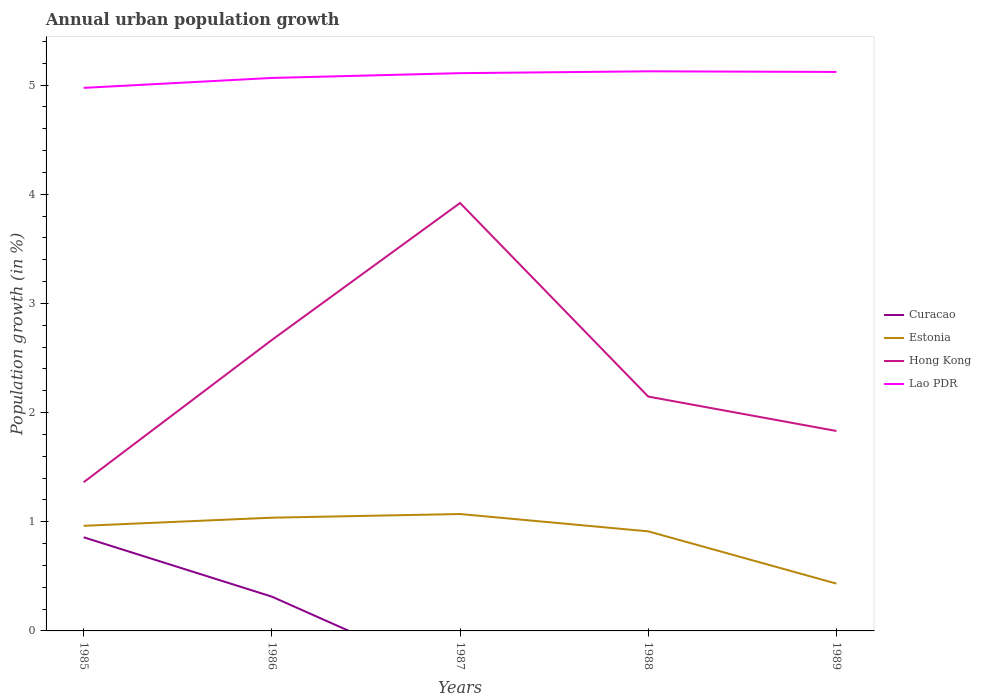Is the number of lines equal to the number of legend labels?
Ensure brevity in your answer.  No. Across all years, what is the maximum percentage of urban population growth in Hong Kong?
Your answer should be compact. 1.36. What is the total percentage of urban population growth in Hong Kong in the graph?
Keep it short and to the point. -0.78. What is the difference between the highest and the second highest percentage of urban population growth in Hong Kong?
Ensure brevity in your answer.  2.56. What is the difference between the highest and the lowest percentage of urban population growth in Hong Kong?
Keep it short and to the point. 2. Are the values on the major ticks of Y-axis written in scientific E-notation?
Your answer should be compact. No. Does the graph contain any zero values?
Your answer should be compact. Yes. How many legend labels are there?
Your answer should be very brief. 4. What is the title of the graph?
Your response must be concise. Annual urban population growth. Does "Virgin Islands" appear as one of the legend labels in the graph?
Your answer should be compact. No. What is the label or title of the Y-axis?
Provide a succinct answer. Population growth (in %). What is the Population growth (in %) in Curacao in 1985?
Offer a very short reply. 0.86. What is the Population growth (in %) in Estonia in 1985?
Offer a terse response. 0.96. What is the Population growth (in %) of Hong Kong in 1985?
Keep it short and to the point. 1.36. What is the Population growth (in %) of Lao PDR in 1985?
Make the answer very short. 4.97. What is the Population growth (in %) of Curacao in 1986?
Offer a very short reply. 0.31. What is the Population growth (in %) of Estonia in 1986?
Your answer should be compact. 1.04. What is the Population growth (in %) of Hong Kong in 1986?
Your answer should be very brief. 2.66. What is the Population growth (in %) of Lao PDR in 1986?
Ensure brevity in your answer.  5.06. What is the Population growth (in %) in Estonia in 1987?
Offer a very short reply. 1.07. What is the Population growth (in %) in Hong Kong in 1987?
Provide a succinct answer. 3.92. What is the Population growth (in %) in Lao PDR in 1987?
Make the answer very short. 5.11. What is the Population growth (in %) in Curacao in 1988?
Your response must be concise. 0. What is the Population growth (in %) of Estonia in 1988?
Your answer should be very brief. 0.91. What is the Population growth (in %) of Hong Kong in 1988?
Offer a terse response. 2.15. What is the Population growth (in %) in Lao PDR in 1988?
Offer a terse response. 5.13. What is the Population growth (in %) of Estonia in 1989?
Provide a succinct answer. 0.43. What is the Population growth (in %) of Hong Kong in 1989?
Make the answer very short. 1.83. What is the Population growth (in %) of Lao PDR in 1989?
Your answer should be very brief. 5.12. Across all years, what is the maximum Population growth (in %) in Curacao?
Keep it short and to the point. 0.86. Across all years, what is the maximum Population growth (in %) in Estonia?
Give a very brief answer. 1.07. Across all years, what is the maximum Population growth (in %) in Hong Kong?
Offer a very short reply. 3.92. Across all years, what is the maximum Population growth (in %) of Lao PDR?
Offer a very short reply. 5.13. Across all years, what is the minimum Population growth (in %) of Curacao?
Give a very brief answer. 0. Across all years, what is the minimum Population growth (in %) of Estonia?
Provide a succinct answer. 0.43. Across all years, what is the minimum Population growth (in %) in Hong Kong?
Make the answer very short. 1.36. Across all years, what is the minimum Population growth (in %) in Lao PDR?
Your answer should be very brief. 4.97. What is the total Population growth (in %) of Curacao in the graph?
Ensure brevity in your answer.  1.17. What is the total Population growth (in %) of Estonia in the graph?
Provide a short and direct response. 4.42. What is the total Population growth (in %) in Hong Kong in the graph?
Keep it short and to the point. 11.92. What is the total Population growth (in %) in Lao PDR in the graph?
Offer a terse response. 25.39. What is the difference between the Population growth (in %) of Curacao in 1985 and that in 1986?
Your answer should be very brief. 0.54. What is the difference between the Population growth (in %) in Estonia in 1985 and that in 1986?
Your answer should be compact. -0.07. What is the difference between the Population growth (in %) of Hong Kong in 1985 and that in 1986?
Your answer should be compact. -1.3. What is the difference between the Population growth (in %) of Lao PDR in 1985 and that in 1986?
Offer a very short reply. -0.09. What is the difference between the Population growth (in %) in Estonia in 1985 and that in 1987?
Your response must be concise. -0.11. What is the difference between the Population growth (in %) in Hong Kong in 1985 and that in 1987?
Your answer should be very brief. -2.56. What is the difference between the Population growth (in %) of Lao PDR in 1985 and that in 1987?
Your answer should be compact. -0.13. What is the difference between the Population growth (in %) in Estonia in 1985 and that in 1988?
Offer a very short reply. 0.05. What is the difference between the Population growth (in %) in Hong Kong in 1985 and that in 1988?
Provide a succinct answer. -0.78. What is the difference between the Population growth (in %) of Lao PDR in 1985 and that in 1988?
Your response must be concise. -0.15. What is the difference between the Population growth (in %) of Estonia in 1985 and that in 1989?
Make the answer very short. 0.53. What is the difference between the Population growth (in %) in Hong Kong in 1985 and that in 1989?
Keep it short and to the point. -0.47. What is the difference between the Population growth (in %) of Lao PDR in 1985 and that in 1989?
Your answer should be very brief. -0.15. What is the difference between the Population growth (in %) in Estonia in 1986 and that in 1987?
Keep it short and to the point. -0.03. What is the difference between the Population growth (in %) of Hong Kong in 1986 and that in 1987?
Provide a short and direct response. -1.25. What is the difference between the Population growth (in %) in Lao PDR in 1986 and that in 1987?
Give a very brief answer. -0.04. What is the difference between the Population growth (in %) in Estonia in 1986 and that in 1988?
Offer a very short reply. 0.13. What is the difference between the Population growth (in %) in Hong Kong in 1986 and that in 1988?
Provide a short and direct response. 0.52. What is the difference between the Population growth (in %) of Lao PDR in 1986 and that in 1988?
Ensure brevity in your answer.  -0.06. What is the difference between the Population growth (in %) of Estonia in 1986 and that in 1989?
Provide a succinct answer. 0.6. What is the difference between the Population growth (in %) of Hong Kong in 1986 and that in 1989?
Your response must be concise. 0.83. What is the difference between the Population growth (in %) in Lao PDR in 1986 and that in 1989?
Provide a short and direct response. -0.06. What is the difference between the Population growth (in %) of Estonia in 1987 and that in 1988?
Your answer should be very brief. 0.16. What is the difference between the Population growth (in %) of Hong Kong in 1987 and that in 1988?
Your response must be concise. 1.77. What is the difference between the Population growth (in %) in Lao PDR in 1987 and that in 1988?
Your response must be concise. -0.02. What is the difference between the Population growth (in %) of Estonia in 1987 and that in 1989?
Keep it short and to the point. 0.64. What is the difference between the Population growth (in %) of Hong Kong in 1987 and that in 1989?
Your answer should be compact. 2.09. What is the difference between the Population growth (in %) in Lao PDR in 1987 and that in 1989?
Keep it short and to the point. -0.01. What is the difference between the Population growth (in %) in Estonia in 1988 and that in 1989?
Give a very brief answer. 0.48. What is the difference between the Population growth (in %) in Hong Kong in 1988 and that in 1989?
Keep it short and to the point. 0.32. What is the difference between the Population growth (in %) of Lao PDR in 1988 and that in 1989?
Your response must be concise. 0.01. What is the difference between the Population growth (in %) of Curacao in 1985 and the Population growth (in %) of Estonia in 1986?
Keep it short and to the point. -0.18. What is the difference between the Population growth (in %) in Curacao in 1985 and the Population growth (in %) in Hong Kong in 1986?
Your answer should be compact. -1.81. What is the difference between the Population growth (in %) of Curacao in 1985 and the Population growth (in %) of Lao PDR in 1986?
Ensure brevity in your answer.  -4.21. What is the difference between the Population growth (in %) of Estonia in 1985 and the Population growth (in %) of Hong Kong in 1986?
Your answer should be very brief. -1.7. What is the difference between the Population growth (in %) in Estonia in 1985 and the Population growth (in %) in Lao PDR in 1986?
Your answer should be compact. -4.1. What is the difference between the Population growth (in %) of Hong Kong in 1985 and the Population growth (in %) of Lao PDR in 1986?
Offer a terse response. -3.7. What is the difference between the Population growth (in %) in Curacao in 1985 and the Population growth (in %) in Estonia in 1987?
Provide a short and direct response. -0.21. What is the difference between the Population growth (in %) in Curacao in 1985 and the Population growth (in %) in Hong Kong in 1987?
Offer a terse response. -3.06. What is the difference between the Population growth (in %) of Curacao in 1985 and the Population growth (in %) of Lao PDR in 1987?
Ensure brevity in your answer.  -4.25. What is the difference between the Population growth (in %) of Estonia in 1985 and the Population growth (in %) of Hong Kong in 1987?
Ensure brevity in your answer.  -2.96. What is the difference between the Population growth (in %) in Estonia in 1985 and the Population growth (in %) in Lao PDR in 1987?
Offer a terse response. -4.15. What is the difference between the Population growth (in %) of Hong Kong in 1985 and the Population growth (in %) of Lao PDR in 1987?
Keep it short and to the point. -3.75. What is the difference between the Population growth (in %) in Curacao in 1985 and the Population growth (in %) in Estonia in 1988?
Your answer should be very brief. -0.05. What is the difference between the Population growth (in %) in Curacao in 1985 and the Population growth (in %) in Hong Kong in 1988?
Offer a terse response. -1.29. What is the difference between the Population growth (in %) in Curacao in 1985 and the Population growth (in %) in Lao PDR in 1988?
Your response must be concise. -4.27. What is the difference between the Population growth (in %) in Estonia in 1985 and the Population growth (in %) in Hong Kong in 1988?
Offer a terse response. -1.18. What is the difference between the Population growth (in %) in Estonia in 1985 and the Population growth (in %) in Lao PDR in 1988?
Provide a short and direct response. -4.16. What is the difference between the Population growth (in %) of Hong Kong in 1985 and the Population growth (in %) of Lao PDR in 1988?
Offer a terse response. -3.76. What is the difference between the Population growth (in %) in Curacao in 1985 and the Population growth (in %) in Estonia in 1989?
Make the answer very short. 0.42. What is the difference between the Population growth (in %) of Curacao in 1985 and the Population growth (in %) of Hong Kong in 1989?
Make the answer very short. -0.97. What is the difference between the Population growth (in %) of Curacao in 1985 and the Population growth (in %) of Lao PDR in 1989?
Your answer should be very brief. -4.26. What is the difference between the Population growth (in %) of Estonia in 1985 and the Population growth (in %) of Hong Kong in 1989?
Your answer should be very brief. -0.87. What is the difference between the Population growth (in %) in Estonia in 1985 and the Population growth (in %) in Lao PDR in 1989?
Offer a very short reply. -4.16. What is the difference between the Population growth (in %) in Hong Kong in 1985 and the Population growth (in %) in Lao PDR in 1989?
Your answer should be compact. -3.76. What is the difference between the Population growth (in %) of Curacao in 1986 and the Population growth (in %) of Estonia in 1987?
Keep it short and to the point. -0.76. What is the difference between the Population growth (in %) in Curacao in 1986 and the Population growth (in %) in Hong Kong in 1987?
Your response must be concise. -3.61. What is the difference between the Population growth (in %) in Curacao in 1986 and the Population growth (in %) in Lao PDR in 1987?
Provide a short and direct response. -4.79. What is the difference between the Population growth (in %) in Estonia in 1986 and the Population growth (in %) in Hong Kong in 1987?
Ensure brevity in your answer.  -2.88. What is the difference between the Population growth (in %) in Estonia in 1986 and the Population growth (in %) in Lao PDR in 1987?
Your answer should be very brief. -4.07. What is the difference between the Population growth (in %) in Hong Kong in 1986 and the Population growth (in %) in Lao PDR in 1987?
Provide a succinct answer. -2.44. What is the difference between the Population growth (in %) of Curacao in 1986 and the Population growth (in %) of Estonia in 1988?
Your answer should be very brief. -0.6. What is the difference between the Population growth (in %) in Curacao in 1986 and the Population growth (in %) in Hong Kong in 1988?
Make the answer very short. -1.83. What is the difference between the Population growth (in %) of Curacao in 1986 and the Population growth (in %) of Lao PDR in 1988?
Your answer should be very brief. -4.81. What is the difference between the Population growth (in %) of Estonia in 1986 and the Population growth (in %) of Hong Kong in 1988?
Keep it short and to the point. -1.11. What is the difference between the Population growth (in %) in Estonia in 1986 and the Population growth (in %) in Lao PDR in 1988?
Your answer should be compact. -4.09. What is the difference between the Population growth (in %) in Hong Kong in 1986 and the Population growth (in %) in Lao PDR in 1988?
Your response must be concise. -2.46. What is the difference between the Population growth (in %) in Curacao in 1986 and the Population growth (in %) in Estonia in 1989?
Provide a short and direct response. -0.12. What is the difference between the Population growth (in %) in Curacao in 1986 and the Population growth (in %) in Hong Kong in 1989?
Your response must be concise. -1.52. What is the difference between the Population growth (in %) in Curacao in 1986 and the Population growth (in %) in Lao PDR in 1989?
Make the answer very short. -4.81. What is the difference between the Population growth (in %) in Estonia in 1986 and the Population growth (in %) in Hong Kong in 1989?
Your response must be concise. -0.79. What is the difference between the Population growth (in %) in Estonia in 1986 and the Population growth (in %) in Lao PDR in 1989?
Provide a succinct answer. -4.08. What is the difference between the Population growth (in %) in Hong Kong in 1986 and the Population growth (in %) in Lao PDR in 1989?
Your response must be concise. -2.45. What is the difference between the Population growth (in %) of Estonia in 1987 and the Population growth (in %) of Hong Kong in 1988?
Offer a terse response. -1.08. What is the difference between the Population growth (in %) in Estonia in 1987 and the Population growth (in %) in Lao PDR in 1988?
Make the answer very short. -4.05. What is the difference between the Population growth (in %) in Hong Kong in 1987 and the Population growth (in %) in Lao PDR in 1988?
Offer a terse response. -1.21. What is the difference between the Population growth (in %) of Estonia in 1987 and the Population growth (in %) of Hong Kong in 1989?
Make the answer very short. -0.76. What is the difference between the Population growth (in %) of Estonia in 1987 and the Population growth (in %) of Lao PDR in 1989?
Give a very brief answer. -4.05. What is the difference between the Population growth (in %) in Hong Kong in 1987 and the Population growth (in %) in Lao PDR in 1989?
Your response must be concise. -1.2. What is the difference between the Population growth (in %) in Estonia in 1988 and the Population growth (in %) in Hong Kong in 1989?
Make the answer very short. -0.92. What is the difference between the Population growth (in %) in Estonia in 1988 and the Population growth (in %) in Lao PDR in 1989?
Offer a terse response. -4.21. What is the difference between the Population growth (in %) of Hong Kong in 1988 and the Population growth (in %) of Lao PDR in 1989?
Offer a very short reply. -2.97. What is the average Population growth (in %) of Curacao per year?
Your response must be concise. 0.23. What is the average Population growth (in %) in Estonia per year?
Keep it short and to the point. 0.88. What is the average Population growth (in %) in Hong Kong per year?
Your answer should be very brief. 2.38. What is the average Population growth (in %) of Lao PDR per year?
Offer a very short reply. 5.08. In the year 1985, what is the difference between the Population growth (in %) in Curacao and Population growth (in %) in Estonia?
Give a very brief answer. -0.11. In the year 1985, what is the difference between the Population growth (in %) in Curacao and Population growth (in %) in Hong Kong?
Offer a very short reply. -0.5. In the year 1985, what is the difference between the Population growth (in %) of Curacao and Population growth (in %) of Lao PDR?
Ensure brevity in your answer.  -4.12. In the year 1985, what is the difference between the Population growth (in %) of Estonia and Population growth (in %) of Hong Kong?
Your response must be concise. -0.4. In the year 1985, what is the difference between the Population growth (in %) of Estonia and Population growth (in %) of Lao PDR?
Provide a short and direct response. -4.01. In the year 1985, what is the difference between the Population growth (in %) of Hong Kong and Population growth (in %) of Lao PDR?
Provide a succinct answer. -3.61. In the year 1986, what is the difference between the Population growth (in %) of Curacao and Population growth (in %) of Estonia?
Provide a succinct answer. -0.72. In the year 1986, what is the difference between the Population growth (in %) of Curacao and Population growth (in %) of Hong Kong?
Your answer should be very brief. -2.35. In the year 1986, what is the difference between the Population growth (in %) in Curacao and Population growth (in %) in Lao PDR?
Give a very brief answer. -4.75. In the year 1986, what is the difference between the Population growth (in %) of Estonia and Population growth (in %) of Hong Kong?
Provide a succinct answer. -1.63. In the year 1986, what is the difference between the Population growth (in %) of Estonia and Population growth (in %) of Lao PDR?
Keep it short and to the point. -4.03. In the year 1986, what is the difference between the Population growth (in %) in Hong Kong and Population growth (in %) in Lao PDR?
Provide a succinct answer. -2.4. In the year 1987, what is the difference between the Population growth (in %) in Estonia and Population growth (in %) in Hong Kong?
Give a very brief answer. -2.85. In the year 1987, what is the difference between the Population growth (in %) in Estonia and Population growth (in %) in Lao PDR?
Offer a terse response. -4.04. In the year 1987, what is the difference between the Population growth (in %) of Hong Kong and Population growth (in %) of Lao PDR?
Provide a short and direct response. -1.19. In the year 1988, what is the difference between the Population growth (in %) in Estonia and Population growth (in %) in Hong Kong?
Give a very brief answer. -1.23. In the year 1988, what is the difference between the Population growth (in %) of Estonia and Population growth (in %) of Lao PDR?
Make the answer very short. -4.21. In the year 1988, what is the difference between the Population growth (in %) of Hong Kong and Population growth (in %) of Lao PDR?
Make the answer very short. -2.98. In the year 1989, what is the difference between the Population growth (in %) of Estonia and Population growth (in %) of Hong Kong?
Provide a short and direct response. -1.4. In the year 1989, what is the difference between the Population growth (in %) of Estonia and Population growth (in %) of Lao PDR?
Keep it short and to the point. -4.69. In the year 1989, what is the difference between the Population growth (in %) in Hong Kong and Population growth (in %) in Lao PDR?
Your answer should be compact. -3.29. What is the ratio of the Population growth (in %) in Curacao in 1985 to that in 1986?
Ensure brevity in your answer.  2.73. What is the ratio of the Population growth (in %) in Estonia in 1985 to that in 1986?
Offer a terse response. 0.93. What is the ratio of the Population growth (in %) of Hong Kong in 1985 to that in 1986?
Provide a succinct answer. 0.51. What is the ratio of the Population growth (in %) of Estonia in 1985 to that in 1987?
Provide a succinct answer. 0.9. What is the ratio of the Population growth (in %) in Hong Kong in 1985 to that in 1987?
Provide a short and direct response. 0.35. What is the ratio of the Population growth (in %) of Lao PDR in 1985 to that in 1987?
Your answer should be compact. 0.97. What is the ratio of the Population growth (in %) of Estonia in 1985 to that in 1988?
Your answer should be compact. 1.06. What is the ratio of the Population growth (in %) of Hong Kong in 1985 to that in 1988?
Keep it short and to the point. 0.63. What is the ratio of the Population growth (in %) of Lao PDR in 1985 to that in 1988?
Your response must be concise. 0.97. What is the ratio of the Population growth (in %) of Estonia in 1985 to that in 1989?
Provide a short and direct response. 2.22. What is the ratio of the Population growth (in %) of Hong Kong in 1985 to that in 1989?
Make the answer very short. 0.74. What is the ratio of the Population growth (in %) of Lao PDR in 1985 to that in 1989?
Ensure brevity in your answer.  0.97. What is the ratio of the Population growth (in %) in Estonia in 1986 to that in 1987?
Make the answer very short. 0.97. What is the ratio of the Population growth (in %) in Hong Kong in 1986 to that in 1987?
Make the answer very short. 0.68. What is the ratio of the Population growth (in %) in Lao PDR in 1986 to that in 1987?
Give a very brief answer. 0.99. What is the ratio of the Population growth (in %) in Estonia in 1986 to that in 1988?
Give a very brief answer. 1.14. What is the ratio of the Population growth (in %) in Hong Kong in 1986 to that in 1988?
Make the answer very short. 1.24. What is the ratio of the Population growth (in %) of Estonia in 1986 to that in 1989?
Provide a succinct answer. 2.39. What is the ratio of the Population growth (in %) in Hong Kong in 1986 to that in 1989?
Your answer should be very brief. 1.46. What is the ratio of the Population growth (in %) in Lao PDR in 1986 to that in 1989?
Your answer should be very brief. 0.99. What is the ratio of the Population growth (in %) in Estonia in 1987 to that in 1988?
Your answer should be very brief. 1.17. What is the ratio of the Population growth (in %) of Hong Kong in 1987 to that in 1988?
Ensure brevity in your answer.  1.83. What is the ratio of the Population growth (in %) of Lao PDR in 1987 to that in 1988?
Provide a short and direct response. 1. What is the ratio of the Population growth (in %) of Estonia in 1987 to that in 1989?
Offer a terse response. 2.47. What is the ratio of the Population growth (in %) of Hong Kong in 1987 to that in 1989?
Ensure brevity in your answer.  2.14. What is the ratio of the Population growth (in %) in Estonia in 1988 to that in 1989?
Provide a succinct answer. 2.11. What is the ratio of the Population growth (in %) in Hong Kong in 1988 to that in 1989?
Provide a succinct answer. 1.17. What is the difference between the highest and the second highest Population growth (in %) in Estonia?
Your answer should be compact. 0.03. What is the difference between the highest and the second highest Population growth (in %) of Hong Kong?
Give a very brief answer. 1.25. What is the difference between the highest and the second highest Population growth (in %) in Lao PDR?
Give a very brief answer. 0.01. What is the difference between the highest and the lowest Population growth (in %) of Curacao?
Ensure brevity in your answer.  0.86. What is the difference between the highest and the lowest Population growth (in %) of Estonia?
Your response must be concise. 0.64. What is the difference between the highest and the lowest Population growth (in %) of Hong Kong?
Make the answer very short. 2.56. What is the difference between the highest and the lowest Population growth (in %) in Lao PDR?
Your answer should be very brief. 0.15. 